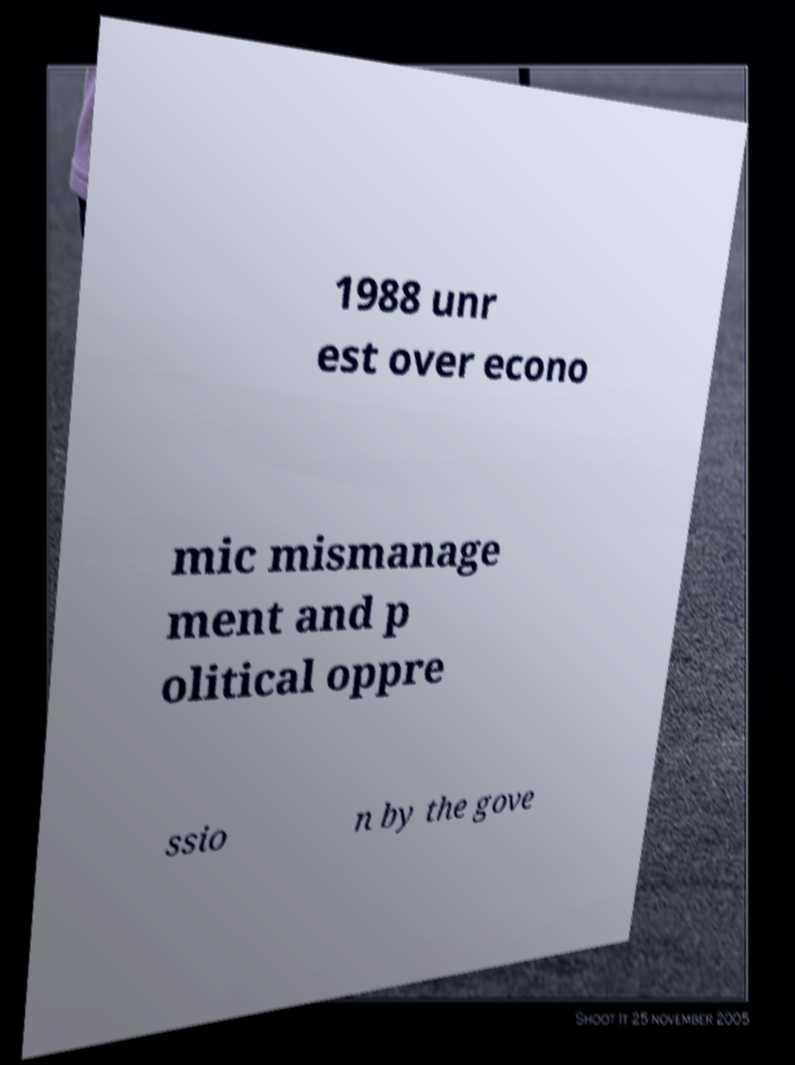Could you extract and type out the text from this image? 1988 unr est over econo mic mismanage ment and p olitical oppre ssio n by the gove 